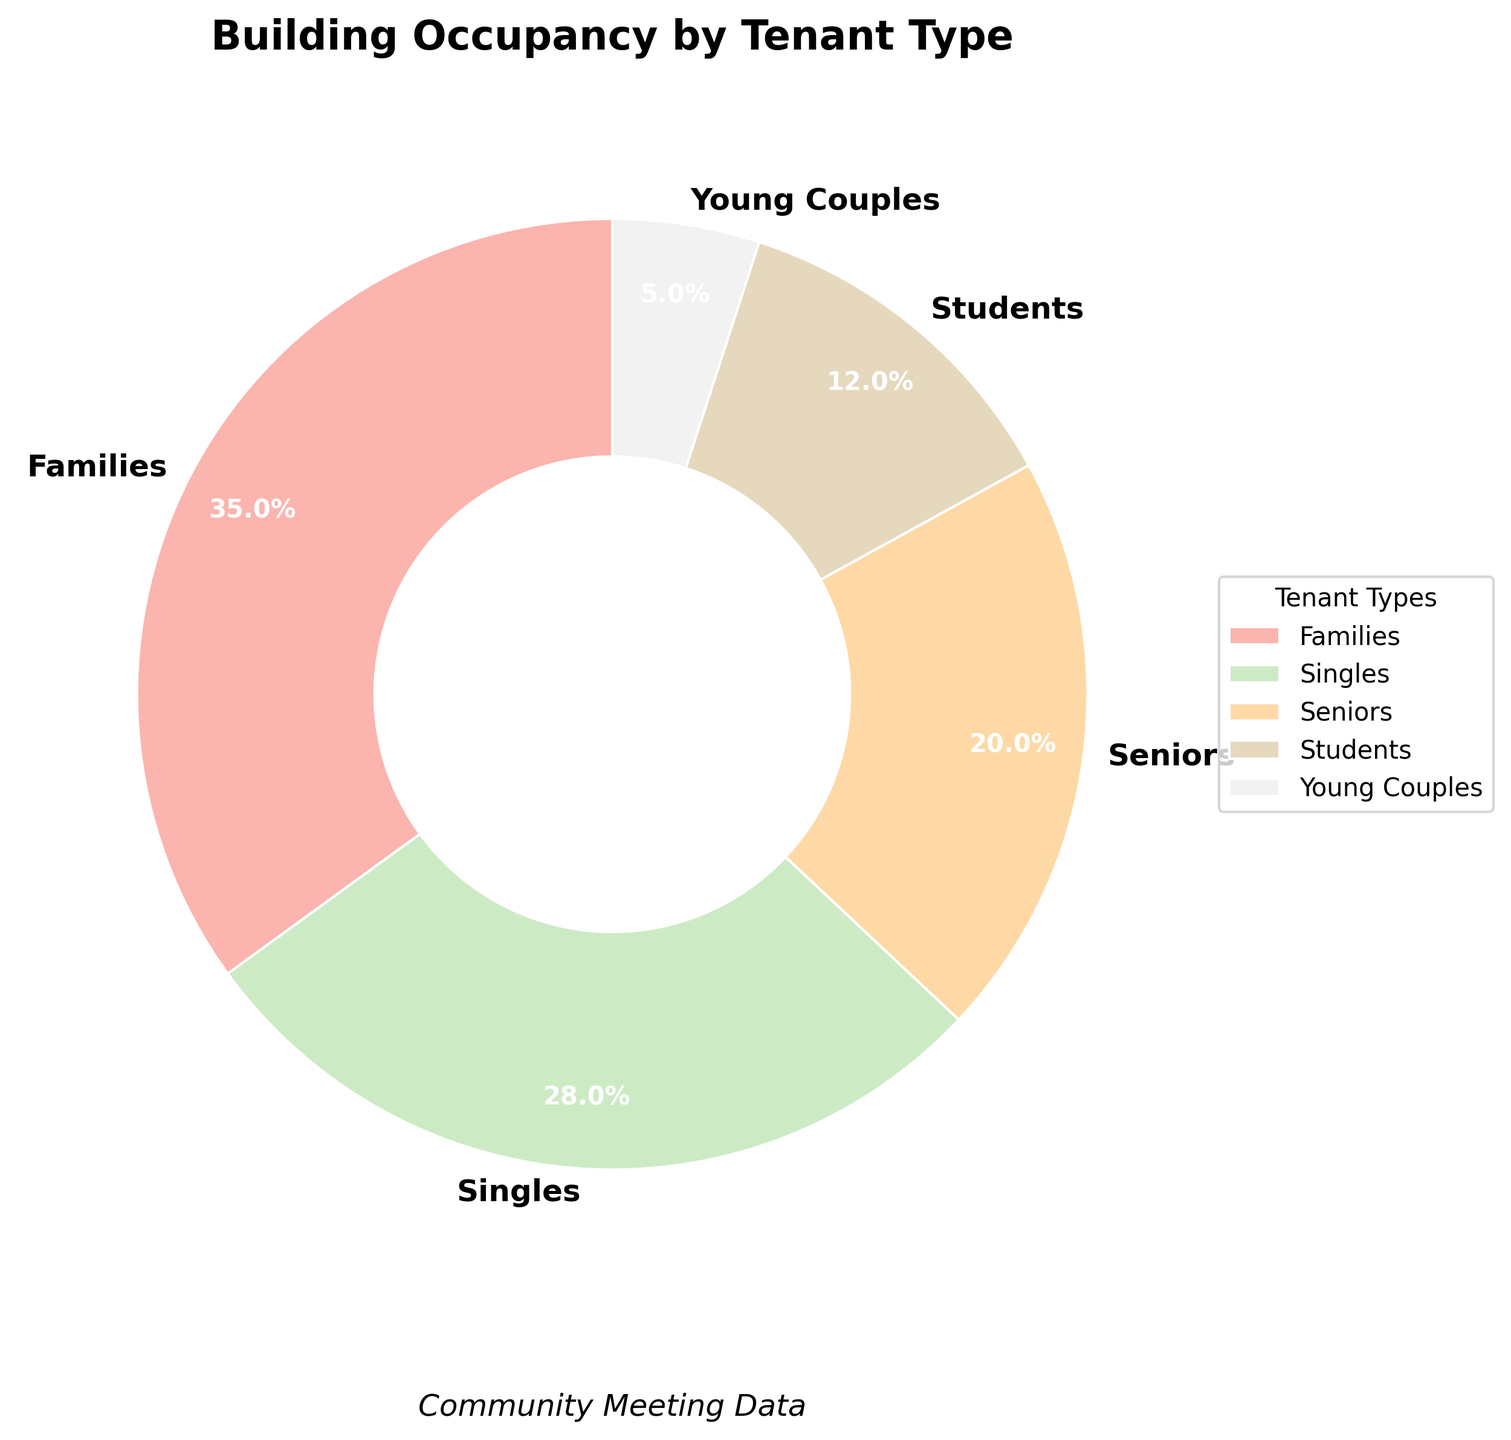What percentage of the building is occupied by seniors and students combined? To find the combined occupancy percentage, sum the percentages of seniors and students. Seniors have 20%, and students have 12%. Therefore, 20% + 12% = 32%.
Answer: 32% What is the difference in occupancy percentage between families and singles? To determine the difference, subtract the percentage of singles from the percentage of families. Families have 35%, and singles have 28%. Therefore, 35% - 28% = 7%.
Answer: 7% Which tenant type occupies a larger portion of the building: seniors or students? Compare the percentages of seniors and students. Seniors occupy 20%, while students occupy 12%. Since 20% is greater than 12%, seniors occupy a larger portion.
Answer: Seniors Are there more families or young couples living in the building? Compare the percentages of families and young couples. Families occupy 35%, and young couples occupy 5%. Since 35% is greater than 5%, there are more families.
Answer: Families What is the most common tenant type in the building? Identify the tenant type with the highest percentage. Families occupy 35%, which is the highest percentage among all tenant types.
Answer: Families Which tenant type has the smallest occupancy percentage? Identify the tenant type with the lowest percentage. Young couples have 5%, which is the smallest percentage among all tenant types.
Answer: Young Couples What percentage of the building is occupied by tenants other than families? Subtract the percentage of families from 100% to find the occupancy by other tenant types. Families occupy 35%, so 100% - 35% = 65%.
Answer: 65% How many tenant types have an occupancy percentage greater than 20%? Determine the tenant types with a percentage above 20%. Families (35%) and singles (28%) are the two tenant types above 20%.
Answer: 2 Which two tenant types together make up more than half of the building's occupancy? Find the combination of two tenant types whose sum exceeds 50%. Families (35%) and singles (28%) together make 35% + 28% = 63%, which is more than half.
Answer: Families and Singles What's the average percentage of occupancy for families, singles, and seniors? Calculate the average by adding the percentages and dividing by the number of tenant types. Families (35%) + Singles (28%) + Seniors (20%) = 83%. Divide by 3: 83% / 3 ≈ 27.67%.
Answer: 27.67% 